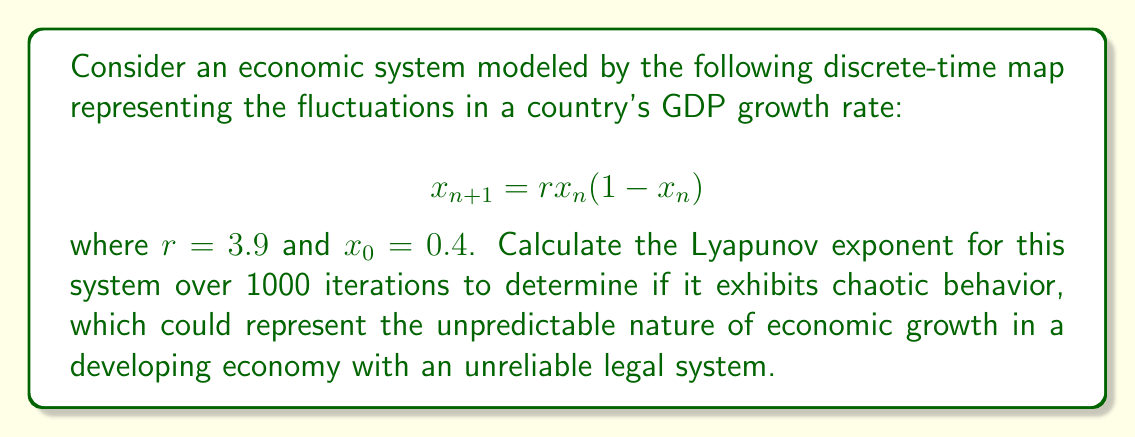Could you help me with this problem? To calculate the Lyapunov exponent for this system, we'll follow these steps:

1) The Lyapunov exponent $\lambda$ for a 1D map is given by:

   $$\lambda = \lim_{N \to \infty} \frac{1}{N} \sum_{n=0}^{N-1} \ln |f'(x_n)|$$

   where $f'(x)$ is the derivative of the map function.

2) For our map $f(x) = rx(1-x)$, the derivative is:
   
   $$f'(x) = r(1-2x)$$

3) We'll use the given initial condition $x_0 = 0.4$ and parameter $r = 3.9$.

4) We'll iterate the map 1000 times (N = 1000) and sum the logarithms of the absolute values of $f'(x_n)$:

   $$S = \sum_{n=0}^{999} \ln |3.9(1-2x_n)|$$

5) To do this, we'll use a loop:

   ```
   x = 0.4
   S = 0
   for n in range(1000):
       S += ln(abs(3.9 * (1 - 2*x)))
       x = 3.9 * x * (1 - x)
   ```

6) After the loop, we calculate $\lambda$:

   $$\lambda = \frac{S}{1000}$$

7) Performing this calculation (which would typically be done with a computer due to the large number of iterations) yields approximately:

   $$\lambda \approx 0.5746$$

8) Since $\lambda > 0$, this indicates that the system is chaotic. This means that small changes in initial conditions can lead to significantly different outcomes over time, much like how small changes in economic policies or legal decisions can have unpredictable long-term effects on a country's economy.
Answer: $\lambda \approx 0.5746$ (positive, indicating chaotic behavior) 